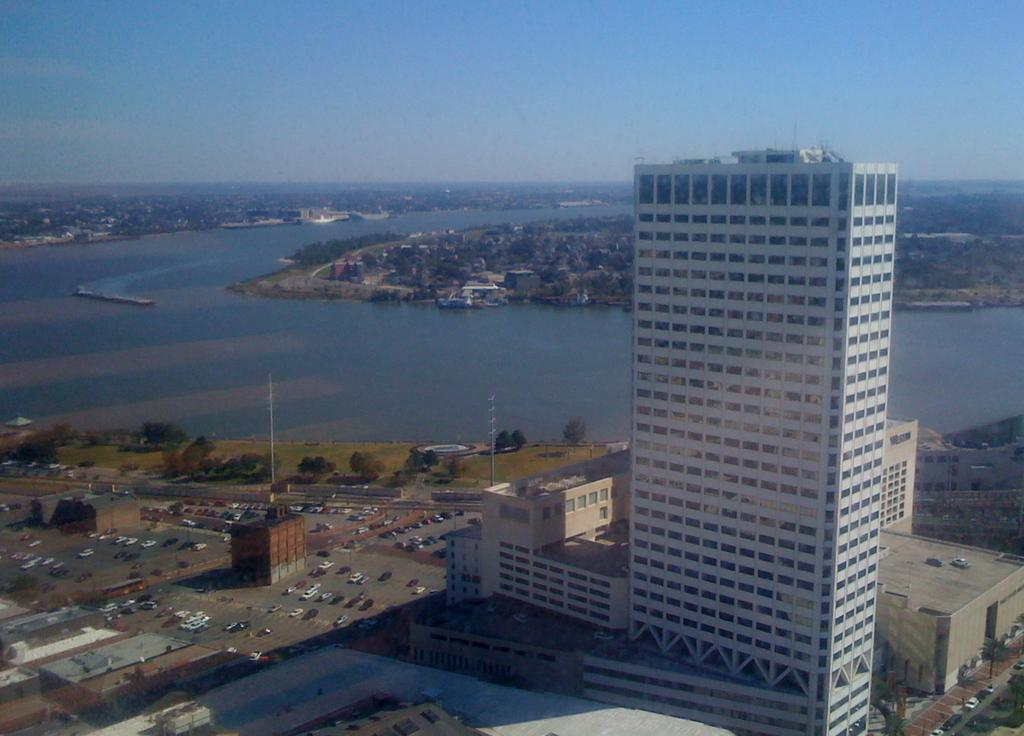What is located in the center of the image? There are buildings in the center of the image. What type of vehicles can be seen on the road in the image? There are cars on the road in the image. What can be seen in the background of the image? There are trees in the background of the image. What type of vegetation is on the ground in the image? There is grass on the ground in the image. What large body of water is visible in the image? There is an ocean visible in the image. How many masks are hanging from the trees in the image? There are no masks present in the image; it features buildings, cars, trees, grass, and an ocean. What type of patch is visible on the ocean in the image? There is no patch visible on the ocean in the image; it is a continuous body of water. 